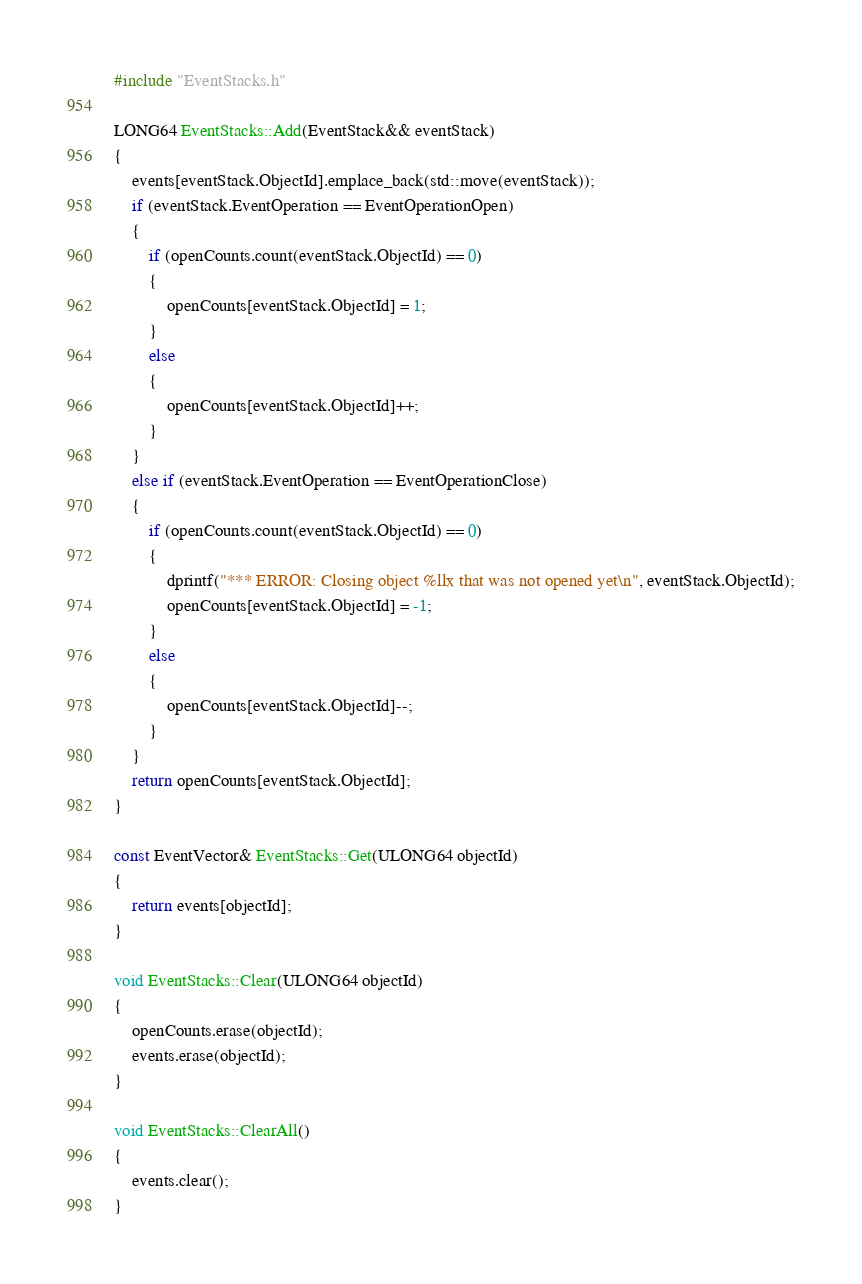<code> <loc_0><loc_0><loc_500><loc_500><_C++_>#include "EventStacks.h"

LONG64 EventStacks::Add(EventStack&& eventStack)
{
	events[eventStack.ObjectId].emplace_back(std::move(eventStack));
	if (eventStack.EventOperation == EventOperationOpen)
	{
		if (openCounts.count(eventStack.ObjectId) == 0)
		{
			openCounts[eventStack.ObjectId] = 1;
		}
		else
		{
			openCounts[eventStack.ObjectId]++;
		}
	}
	else if (eventStack.EventOperation == EventOperationClose)
	{
		if (openCounts.count(eventStack.ObjectId) == 0)
		{
			dprintf("*** ERROR: Closing object %llx that was not opened yet\n", eventStack.ObjectId);
			openCounts[eventStack.ObjectId] = -1;
		}
		else
		{
			openCounts[eventStack.ObjectId]--;
		}
	}
	return openCounts[eventStack.ObjectId];
}

const EventVector& EventStacks::Get(ULONG64 objectId)
{
	return events[objectId];
}

void EventStacks::Clear(ULONG64 objectId)
{
	openCounts.erase(objectId);
	events.erase(objectId);
}

void EventStacks::ClearAll()
{
	events.clear();
}</code> 